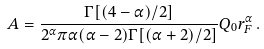<formula> <loc_0><loc_0><loc_500><loc_500>A = \frac { \Gamma [ ( 4 - \alpha ) / 2 ] } { 2 ^ { \alpha } \pi \alpha ( \alpha - 2 ) \Gamma [ ( \alpha + 2 ) / 2 ] } Q _ { 0 } r _ { F } ^ { \alpha } \, .</formula> 